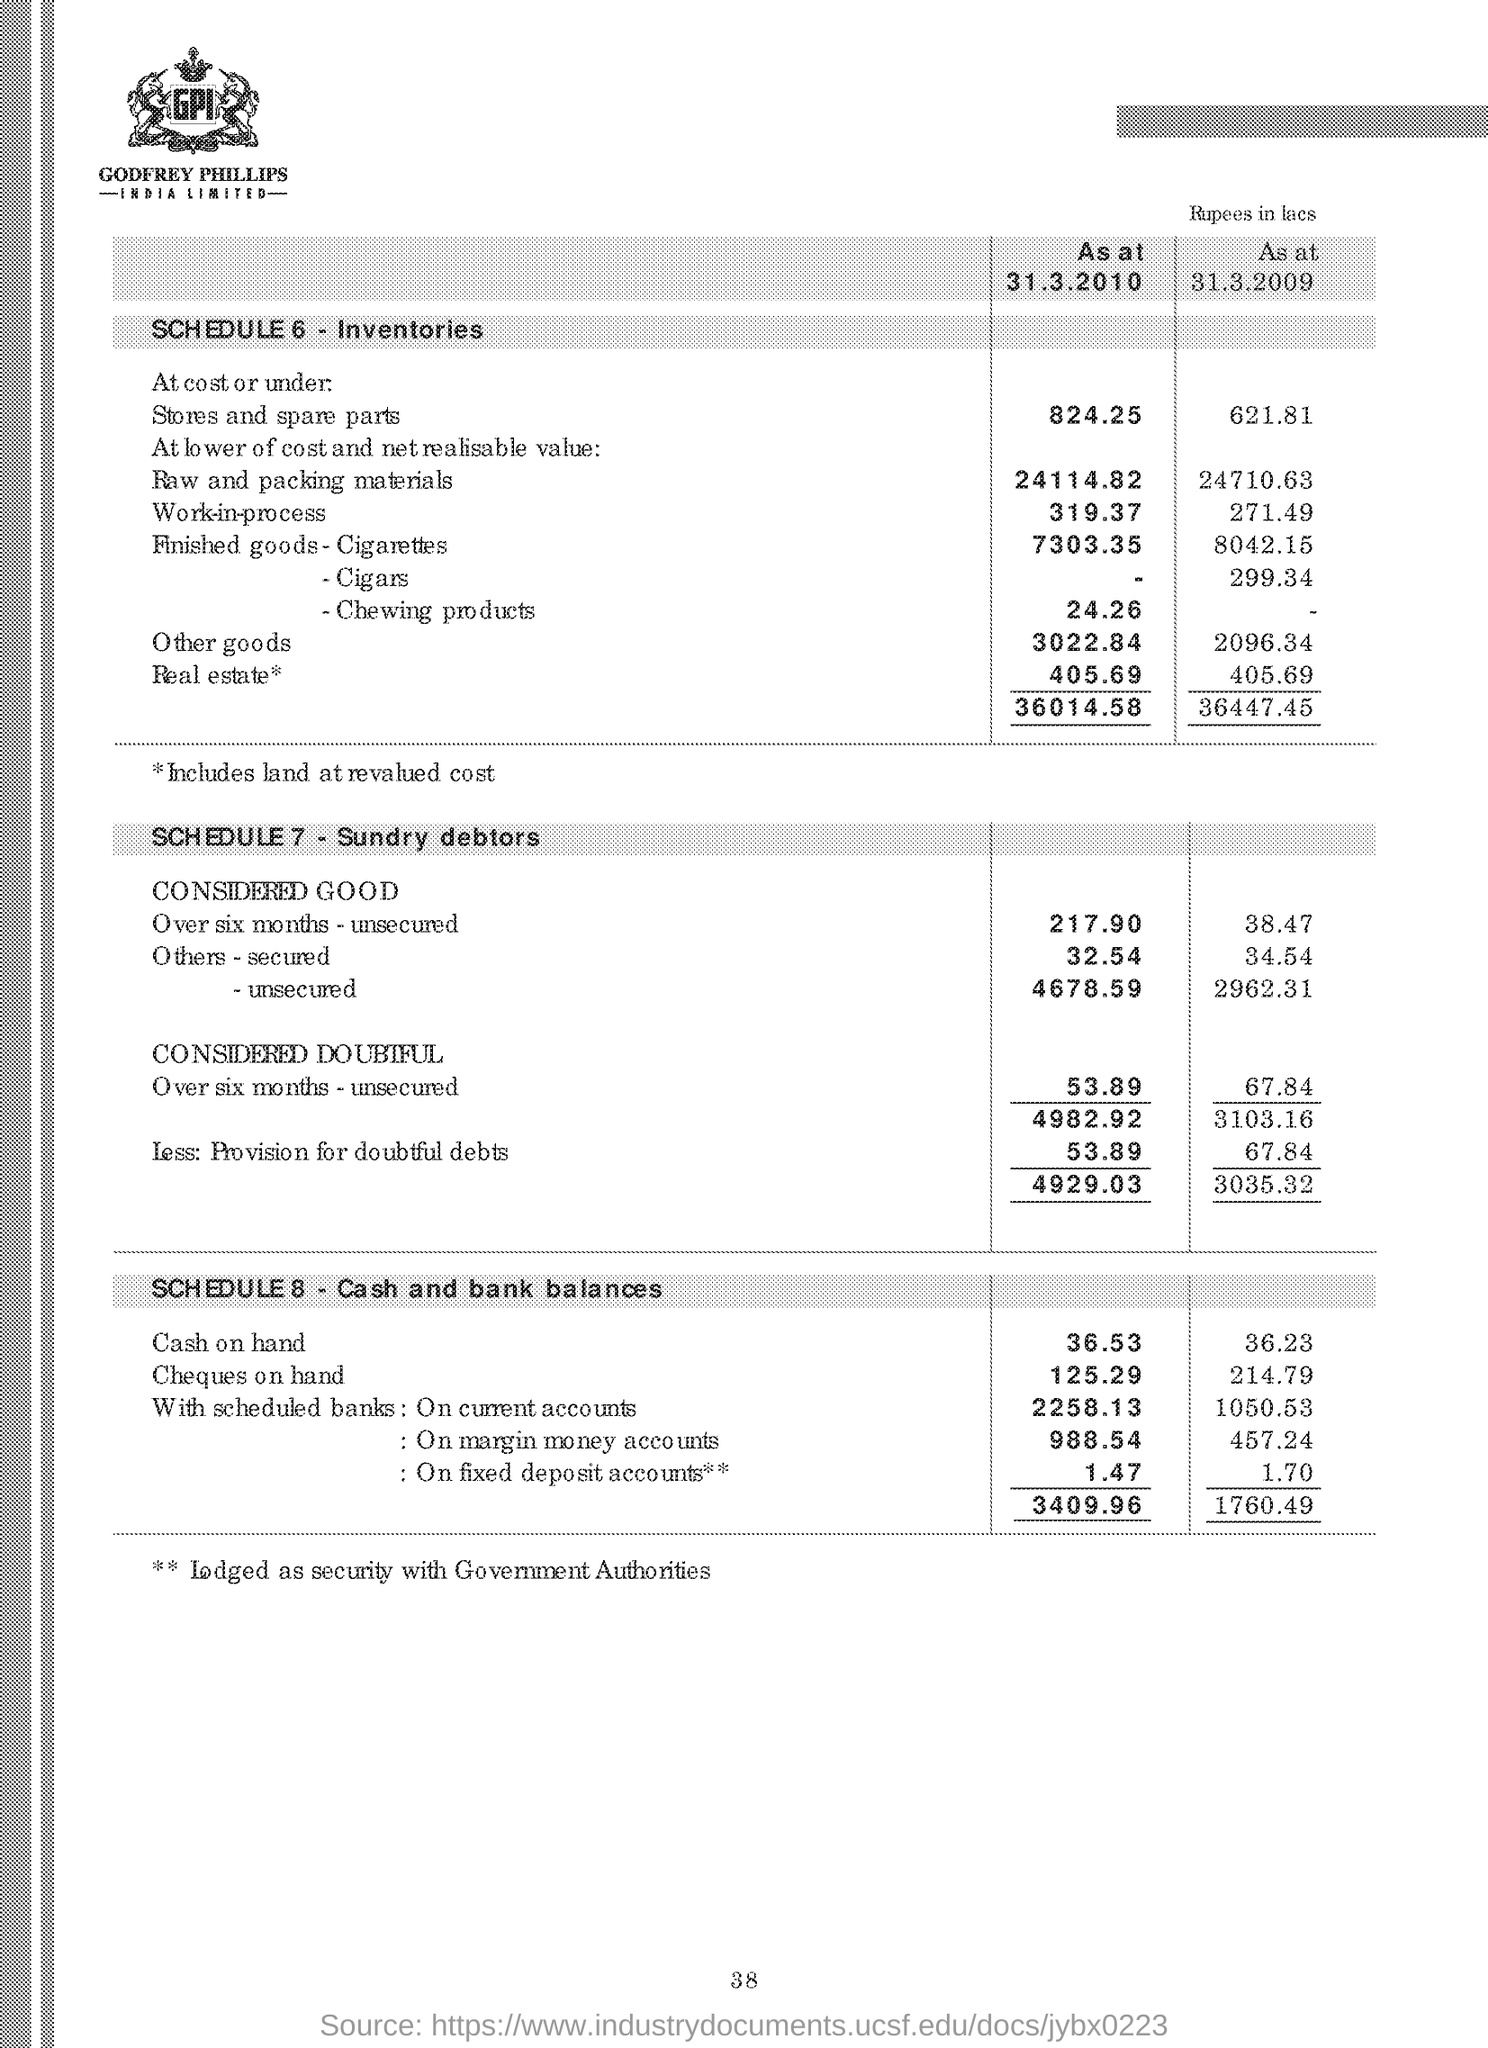What is the text written in the image?
Provide a short and direct response. GPI GODFREY PHILLIPS INDIA LIMITED. 